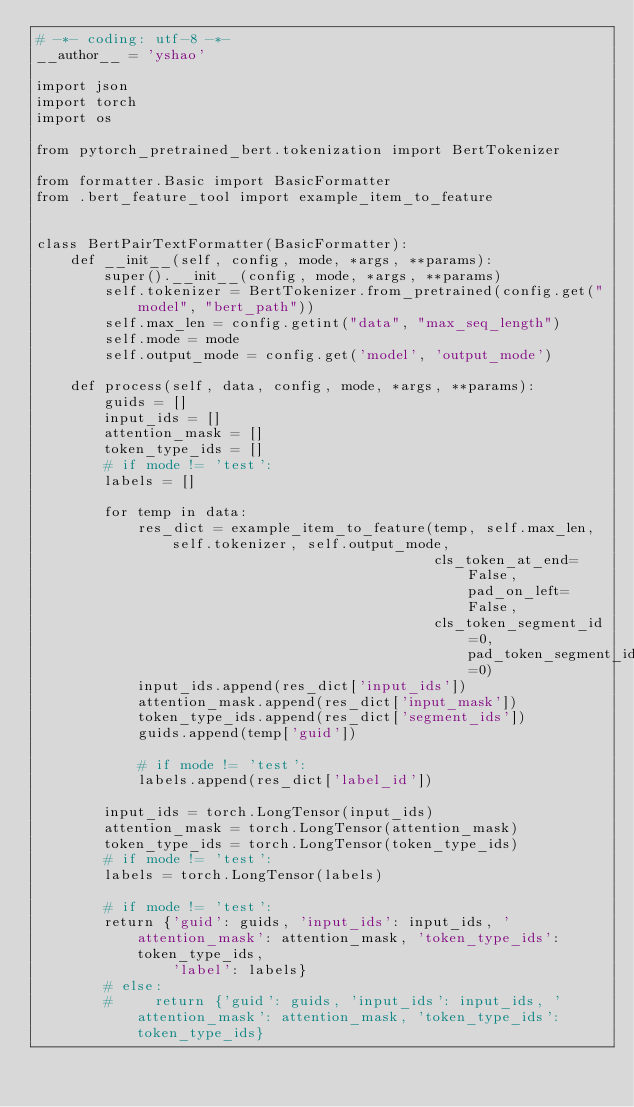Convert code to text. <code><loc_0><loc_0><loc_500><loc_500><_Python_># -*- coding: utf-8 -*-
__author__ = 'yshao'

import json
import torch
import os

from pytorch_pretrained_bert.tokenization import BertTokenizer

from formatter.Basic import BasicFormatter
from .bert_feature_tool import example_item_to_feature


class BertPairTextFormatter(BasicFormatter):
    def __init__(self, config, mode, *args, **params):
        super().__init__(config, mode, *args, **params)
        self.tokenizer = BertTokenizer.from_pretrained(config.get("model", "bert_path"))
        self.max_len = config.getint("data", "max_seq_length")
        self.mode = mode
        self.output_mode = config.get('model', 'output_mode')

    def process(self, data, config, mode, *args, **params):
        guids = []
        input_ids = []
        attention_mask = []
        token_type_ids = []
        # if mode != 'test':
        labels = []

        for temp in data:
            res_dict = example_item_to_feature(temp, self.max_len, self.tokenizer, self.output_mode,
                                               cls_token_at_end=False, pad_on_left=False,
                                               cls_token_segment_id=0, pad_token_segment_id=0)
            input_ids.append(res_dict['input_ids'])
            attention_mask.append(res_dict['input_mask'])
            token_type_ids.append(res_dict['segment_ids'])
            guids.append(temp['guid'])

            # if mode != 'test':
            labels.append(res_dict['label_id'])

        input_ids = torch.LongTensor(input_ids)
        attention_mask = torch.LongTensor(attention_mask)
        token_type_ids = torch.LongTensor(token_type_ids)
        # if mode != 'test':
        labels = torch.LongTensor(labels)

        # if mode != 'test':
        return {'guid': guids, 'input_ids': input_ids, 'attention_mask': attention_mask, 'token_type_ids': token_type_ids,
                'label': labels}
        # else:
        #     return {'guid': guids, 'input_ids': input_ids, 'attention_mask': attention_mask, 'token_type_ids': token_type_ids}





</code> 